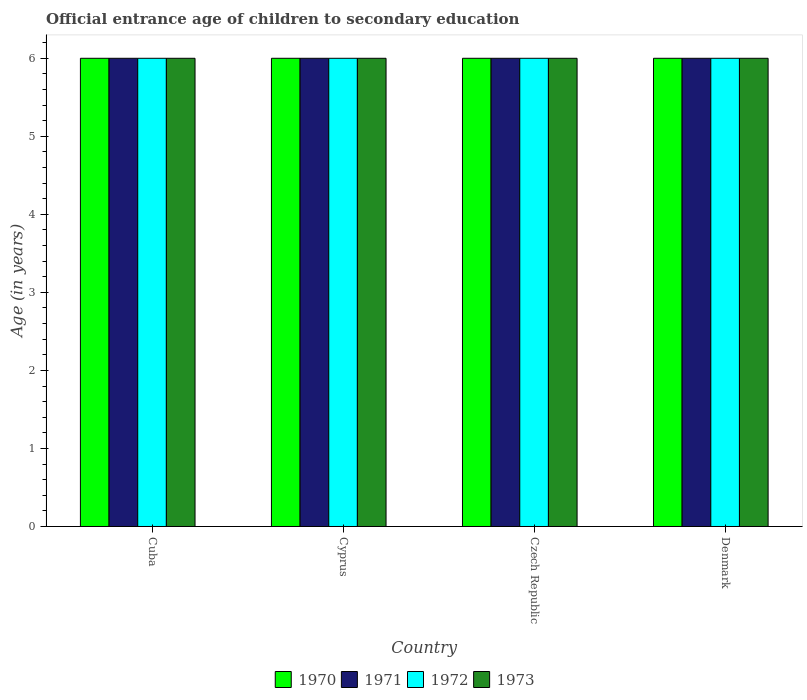How many different coloured bars are there?
Provide a succinct answer. 4. How many bars are there on the 1st tick from the left?
Your answer should be very brief. 4. How many bars are there on the 2nd tick from the right?
Your answer should be very brief. 4. In how many cases, is the number of bars for a given country not equal to the number of legend labels?
Offer a terse response. 0. What is the secondary school starting age of children in 1972 in Denmark?
Make the answer very short. 6. Across all countries, what is the maximum secondary school starting age of children in 1970?
Provide a succinct answer. 6. In which country was the secondary school starting age of children in 1972 maximum?
Offer a very short reply. Cuba. In which country was the secondary school starting age of children in 1971 minimum?
Your response must be concise. Cuba. What is the difference between the secondary school starting age of children in 1973 in Cyprus and the secondary school starting age of children in 1970 in Czech Republic?
Make the answer very short. 0. In how many countries, is the secondary school starting age of children in 1972 greater than 4.4 years?
Offer a very short reply. 4. Is the secondary school starting age of children in 1971 in Czech Republic less than that in Denmark?
Your response must be concise. No. What is the difference between the highest and the lowest secondary school starting age of children in 1972?
Provide a short and direct response. 0. Is the sum of the secondary school starting age of children in 1971 in Cuba and Czech Republic greater than the maximum secondary school starting age of children in 1972 across all countries?
Ensure brevity in your answer.  Yes. Is it the case that in every country, the sum of the secondary school starting age of children in 1972 and secondary school starting age of children in 1971 is greater than the sum of secondary school starting age of children in 1973 and secondary school starting age of children in 1970?
Your answer should be compact. No. Are all the bars in the graph horizontal?
Provide a succinct answer. No. How many countries are there in the graph?
Ensure brevity in your answer.  4. Are the values on the major ticks of Y-axis written in scientific E-notation?
Your answer should be very brief. No. Does the graph contain any zero values?
Your response must be concise. No. Where does the legend appear in the graph?
Offer a terse response. Bottom center. How many legend labels are there?
Ensure brevity in your answer.  4. How are the legend labels stacked?
Provide a short and direct response. Horizontal. What is the title of the graph?
Offer a terse response. Official entrance age of children to secondary education. What is the label or title of the Y-axis?
Your answer should be compact. Age (in years). What is the Age (in years) of 1970 in Cuba?
Your answer should be compact. 6. What is the Age (in years) of 1973 in Cyprus?
Give a very brief answer. 6. What is the Age (in years) of 1970 in Czech Republic?
Make the answer very short. 6. What is the Age (in years) of 1971 in Czech Republic?
Provide a short and direct response. 6. What is the Age (in years) of 1973 in Czech Republic?
Provide a short and direct response. 6. What is the Age (in years) in 1970 in Denmark?
Offer a very short reply. 6. Across all countries, what is the maximum Age (in years) of 1970?
Ensure brevity in your answer.  6. Across all countries, what is the maximum Age (in years) of 1971?
Your answer should be very brief. 6. Across all countries, what is the maximum Age (in years) of 1973?
Provide a short and direct response. 6. Across all countries, what is the minimum Age (in years) of 1970?
Offer a very short reply. 6. Across all countries, what is the minimum Age (in years) in 1971?
Your answer should be compact. 6. Across all countries, what is the minimum Age (in years) in 1972?
Ensure brevity in your answer.  6. What is the total Age (in years) in 1973 in the graph?
Your response must be concise. 24. What is the difference between the Age (in years) of 1971 in Cuba and that in Cyprus?
Ensure brevity in your answer.  0. What is the difference between the Age (in years) of 1973 in Cuba and that in Cyprus?
Your answer should be very brief. 0. What is the difference between the Age (in years) in 1971 in Cuba and that in Czech Republic?
Your answer should be compact. 0. What is the difference between the Age (in years) of 1970 in Cuba and that in Denmark?
Your answer should be very brief. 0. What is the difference between the Age (in years) in 1971 in Cuba and that in Denmark?
Keep it short and to the point. 0. What is the difference between the Age (in years) of 1973 in Cuba and that in Denmark?
Give a very brief answer. 0. What is the difference between the Age (in years) in 1970 in Cyprus and that in Czech Republic?
Offer a very short reply. 0. What is the difference between the Age (in years) of 1971 in Cyprus and that in Czech Republic?
Keep it short and to the point. 0. What is the difference between the Age (in years) of 1973 in Cyprus and that in Czech Republic?
Your answer should be very brief. 0. What is the difference between the Age (in years) of 1970 in Cyprus and that in Denmark?
Your answer should be compact. 0. What is the difference between the Age (in years) in 1971 in Cyprus and that in Denmark?
Provide a succinct answer. 0. What is the difference between the Age (in years) in 1971 in Czech Republic and that in Denmark?
Make the answer very short. 0. What is the difference between the Age (in years) in 1973 in Czech Republic and that in Denmark?
Keep it short and to the point. 0. What is the difference between the Age (in years) in 1970 in Cuba and the Age (in years) in 1971 in Cyprus?
Your answer should be compact. 0. What is the difference between the Age (in years) in 1970 in Cuba and the Age (in years) in 1972 in Cyprus?
Provide a succinct answer. 0. What is the difference between the Age (in years) in 1971 in Cuba and the Age (in years) in 1972 in Cyprus?
Your answer should be very brief. 0. What is the difference between the Age (in years) of 1970 in Cuba and the Age (in years) of 1971 in Czech Republic?
Keep it short and to the point. 0. What is the difference between the Age (in years) in 1970 in Cuba and the Age (in years) in 1972 in Czech Republic?
Offer a terse response. 0. What is the difference between the Age (in years) of 1970 in Cuba and the Age (in years) of 1973 in Czech Republic?
Keep it short and to the point. 0. What is the difference between the Age (in years) in 1971 in Cuba and the Age (in years) in 1972 in Czech Republic?
Your response must be concise. 0. What is the difference between the Age (in years) in 1970 in Cyprus and the Age (in years) in 1971 in Czech Republic?
Keep it short and to the point. 0. What is the difference between the Age (in years) of 1970 in Cyprus and the Age (in years) of 1972 in Czech Republic?
Make the answer very short. 0. What is the difference between the Age (in years) of 1971 in Cyprus and the Age (in years) of 1973 in Czech Republic?
Your answer should be very brief. 0. What is the difference between the Age (in years) of 1970 in Cyprus and the Age (in years) of 1971 in Denmark?
Your answer should be compact. 0. What is the difference between the Age (in years) of 1970 in Czech Republic and the Age (in years) of 1972 in Denmark?
Keep it short and to the point. 0. What is the average Age (in years) in 1971 per country?
Your answer should be very brief. 6. What is the average Age (in years) in 1972 per country?
Make the answer very short. 6. What is the difference between the Age (in years) in 1970 and Age (in years) in 1971 in Cuba?
Offer a very short reply. 0. What is the difference between the Age (in years) of 1970 and Age (in years) of 1972 in Cuba?
Ensure brevity in your answer.  0. What is the difference between the Age (in years) in 1971 and Age (in years) in 1973 in Cuba?
Offer a terse response. 0. What is the difference between the Age (in years) in 1972 and Age (in years) in 1973 in Cuba?
Provide a succinct answer. 0. What is the difference between the Age (in years) in 1970 and Age (in years) in 1972 in Cyprus?
Give a very brief answer. 0. What is the difference between the Age (in years) in 1972 and Age (in years) in 1973 in Cyprus?
Offer a terse response. 0. What is the difference between the Age (in years) of 1970 and Age (in years) of 1972 in Czech Republic?
Keep it short and to the point. 0. What is the difference between the Age (in years) of 1970 and Age (in years) of 1973 in Czech Republic?
Offer a very short reply. 0. What is the difference between the Age (in years) of 1971 and Age (in years) of 1973 in Czech Republic?
Give a very brief answer. 0. What is the difference between the Age (in years) of 1972 and Age (in years) of 1973 in Czech Republic?
Your response must be concise. 0. What is the difference between the Age (in years) in 1970 and Age (in years) in 1971 in Denmark?
Keep it short and to the point. 0. What is the difference between the Age (in years) in 1970 and Age (in years) in 1973 in Denmark?
Make the answer very short. 0. What is the difference between the Age (in years) of 1971 and Age (in years) of 1972 in Denmark?
Ensure brevity in your answer.  0. What is the ratio of the Age (in years) in 1971 in Cuba to that in Cyprus?
Your response must be concise. 1. What is the ratio of the Age (in years) in 1973 in Cuba to that in Cyprus?
Offer a very short reply. 1. What is the ratio of the Age (in years) of 1973 in Cuba to that in Czech Republic?
Your answer should be compact. 1. What is the ratio of the Age (in years) in 1970 in Cuba to that in Denmark?
Give a very brief answer. 1. What is the ratio of the Age (in years) of 1970 in Cyprus to that in Czech Republic?
Your response must be concise. 1. What is the ratio of the Age (in years) in 1972 in Cyprus to that in Denmark?
Make the answer very short. 1. What is the ratio of the Age (in years) in 1973 in Cyprus to that in Denmark?
Your answer should be compact. 1. What is the ratio of the Age (in years) in 1970 in Czech Republic to that in Denmark?
Your response must be concise. 1. What is the ratio of the Age (in years) of 1971 in Czech Republic to that in Denmark?
Your response must be concise. 1. What is the ratio of the Age (in years) in 1972 in Czech Republic to that in Denmark?
Ensure brevity in your answer.  1. What is the difference between the highest and the second highest Age (in years) in 1971?
Your response must be concise. 0. What is the difference between the highest and the second highest Age (in years) in 1972?
Offer a very short reply. 0. What is the difference between the highest and the lowest Age (in years) in 1970?
Your answer should be compact. 0. What is the difference between the highest and the lowest Age (in years) in 1972?
Provide a succinct answer. 0. What is the difference between the highest and the lowest Age (in years) in 1973?
Offer a very short reply. 0. 